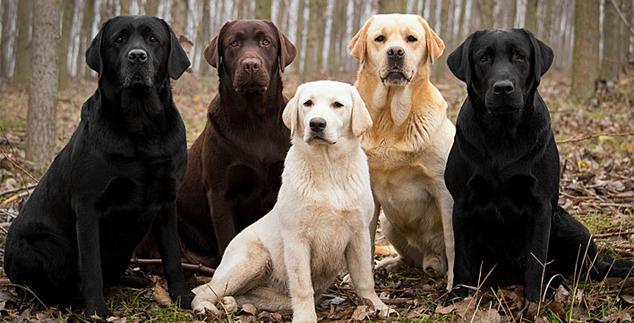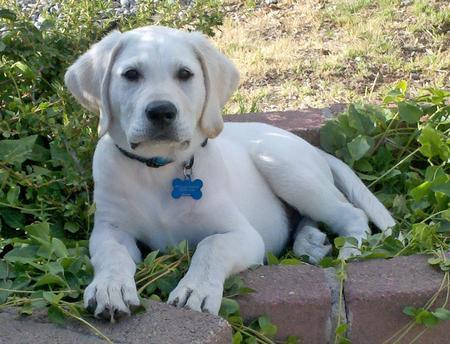The first image is the image on the left, the second image is the image on the right. Given the left and right images, does the statement "One image shows exactly three dogs, each a different color." hold true? Answer yes or no. No. 